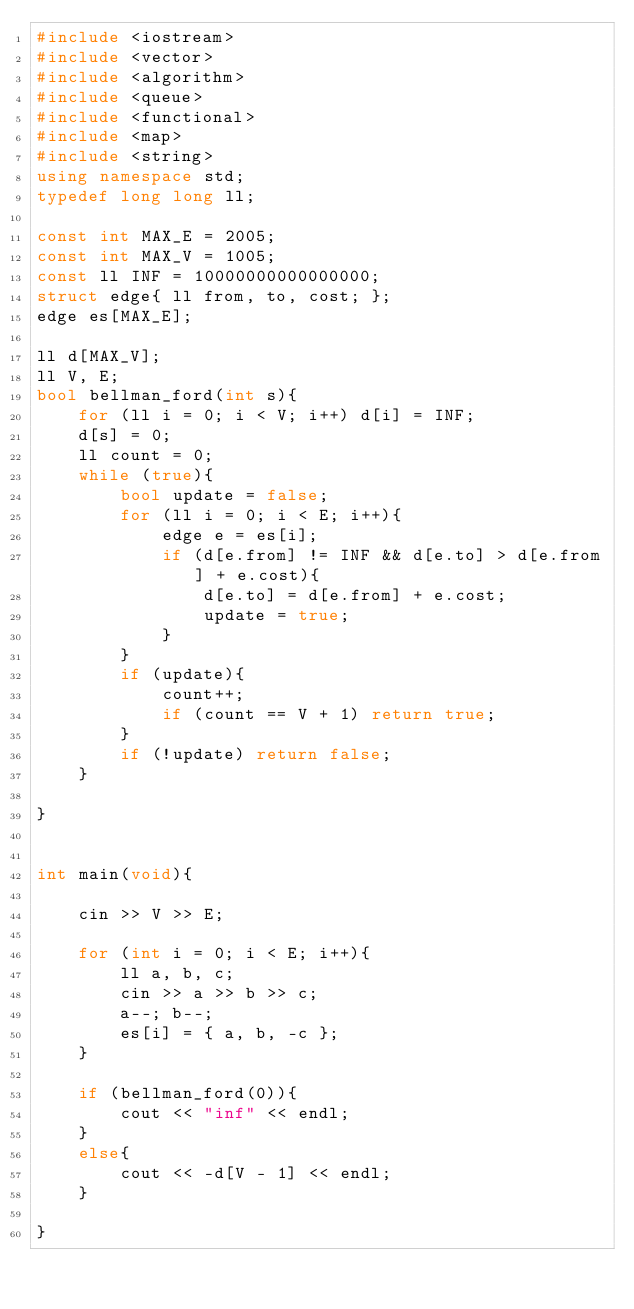<code> <loc_0><loc_0><loc_500><loc_500><_C++_>#include <iostream>
#include <vector>
#include <algorithm> 
#include <queue>
#include <functional>
#include <map>
#include <string>
using namespace std;
typedef long long ll;

const int MAX_E = 2005;
const int MAX_V = 1005;
const ll INF = 10000000000000000;
struct edge{ ll from, to, cost; };
edge es[MAX_E];

ll d[MAX_V];
ll V, E;
bool bellman_ford(int s){
    for (ll i = 0; i < V; i++) d[i] = INF;
    d[s] = 0;
    ll count = 0;
    while (true){
        bool update = false;
        for (ll i = 0; i < E; i++){
            edge e = es[i];
            if (d[e.from] != INF && d[e.to] > d[e.from] + e.cost){
                d[e.to] = d[e.from] + e.cost;
                update = true;
            }
        }
        if (update){
            count++;
            if (count == V + 1) return true;
        }
        if (!update) return false;
    }
  
}


int main(void){

    cin >> V >> E;

    for (int i = 0; i < E; i++){
        ll a, b, c;
        cin >> a >> b >> c;
        a--; b--;
        es[i] = { a, b, -c };
    }

    if (bellman_ford(0)){
        cout << "inf" << endl;
    }
    else{
        cout << -d[V - 1] << endl;
    }

}</code> 